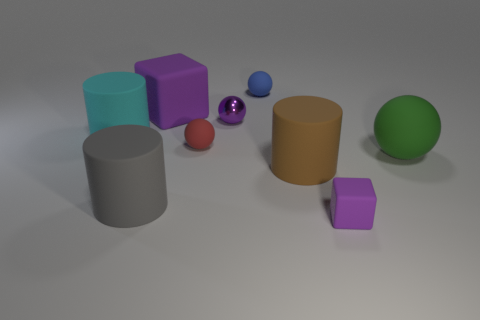There is a block that is the same size as the green sphere; what color is it?
Give a very brief answer. Purple. Are there more purple cubes that are behind the small red rubber sphere than big blocks?
Provide a succinct answer. No. The tiny thing that is both in front of the big cyan matte cylinder and on the left side of the small purple rubber cube is made of what material?
Your answer should be compact. Rubber. There is a small matte thing that is to the left of the blue ball; is it the same color as the matte object that is on the left side of the large gray thing?
Your answer should be compact. No. What number of other objects are there of the same size as the blue object?
Provide a succinct answer. 3. Are there any matte balls to the left of the big purple block that is behind the purple block on the right side of the purple ball?
Your answer should be compact. No. Is the material of the small object left of the small purple metal thing the same as the tiny purple ball?
Give a very brief answer. No. What is the color of the other small matte thing that is the same shape as the red matte object?
Offer a terse response. Blue. Are there any other things that are the same shape as the large brown rubber thing?
Your response must be concise. Yes. Are there an equal number of small blocks behind the big rubber ball and gray metallic spheres?
Offer a terse response. Yes. 